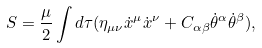<formula> <loc_0><loc_0><loc_500><loc_500>S = \frac { \mu } { 2 } \int d \tau ( \eta _ { \mu \nu } \dot { x } ^ { \mu } \dot { x } ^ { \nu } + C _ { \alpha \beta } \dot { \theta } ^ { \alpha } \dot { \theta } ^ { \beta } ) ,</formula> 